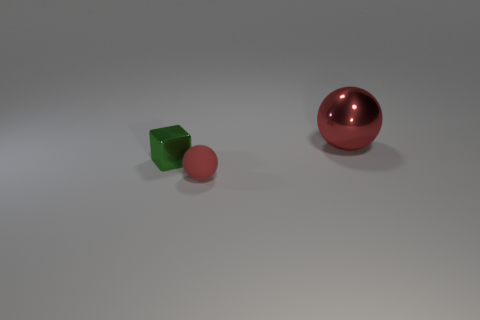What textures can be observed on the objects and which one stands out the most? The objects in the image display different textures. The green cube exhibits a solid, matte finish, the pink ball has a smooth, slightly reflective texture, and the large red sphere has a highly reflective, glossy surface. The reflective glossiness of the large red sphere stands out prominently compared to the others. 